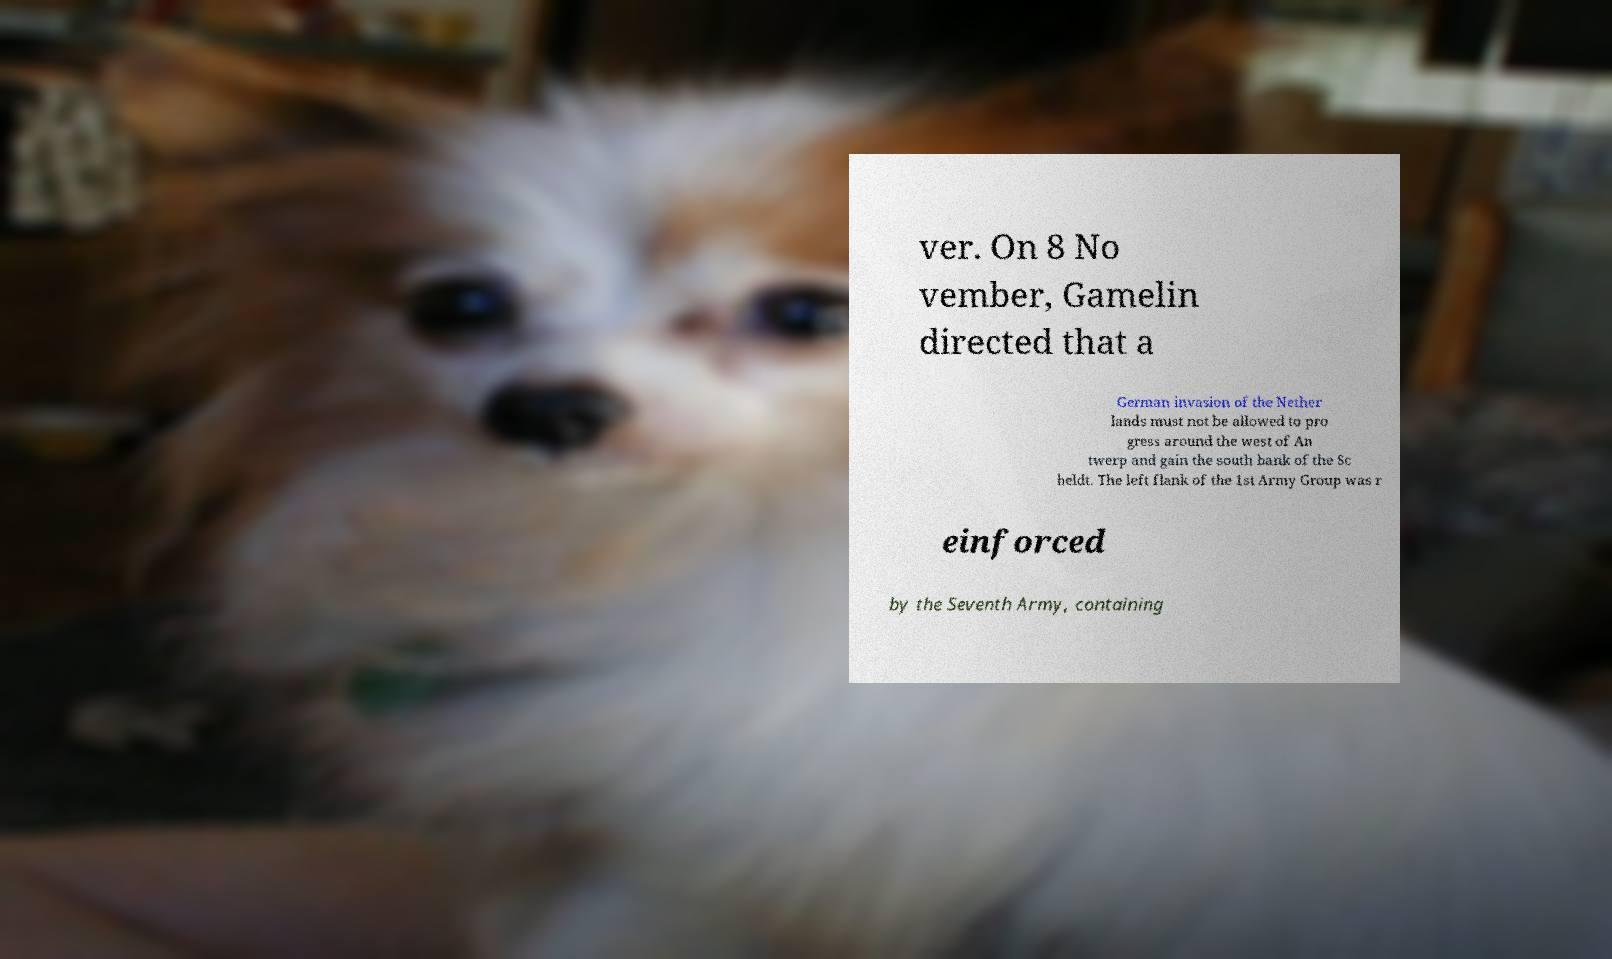Please read and relay the text visible in this image. What does it say? ver. On 8 No vember, Gamelin directed that a German invasion of the Nether lands must not be allowed to pro gress around the west of An twerp and gain the south bank of the Sc heldt. The left flank of the 1st Army Group was r einforced by the Seventh Army, containing 